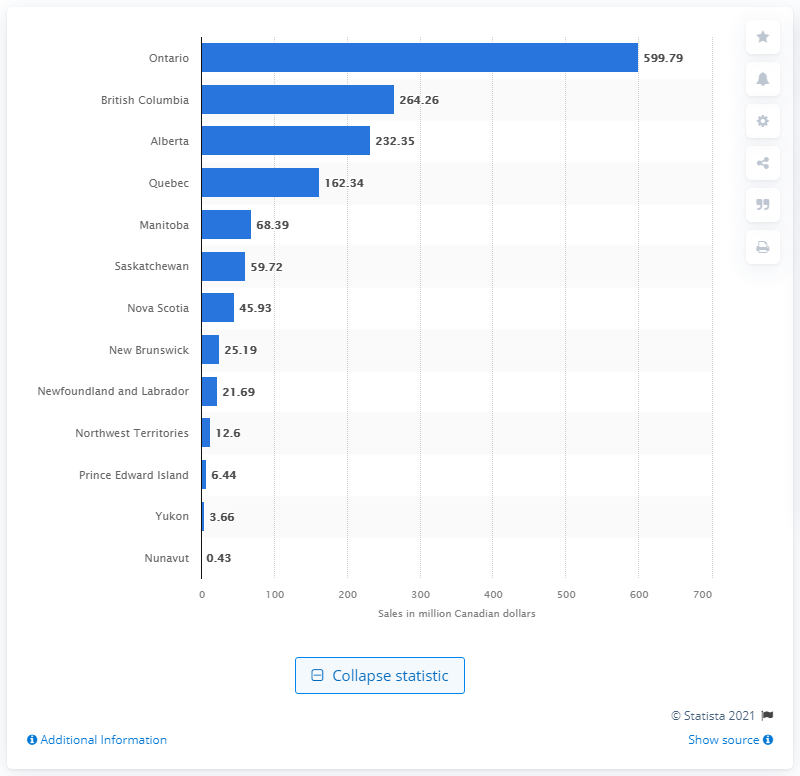List a handful of essential elements in this visual. The sales value of vodka in New Brunswick during the fiscal year ending March 31, 2020, was 25.19 million dollars. According to the data provided, the sales value of vodka in Ontario during the fiscal year ending March 31, 2020 was CAD 599.79. 